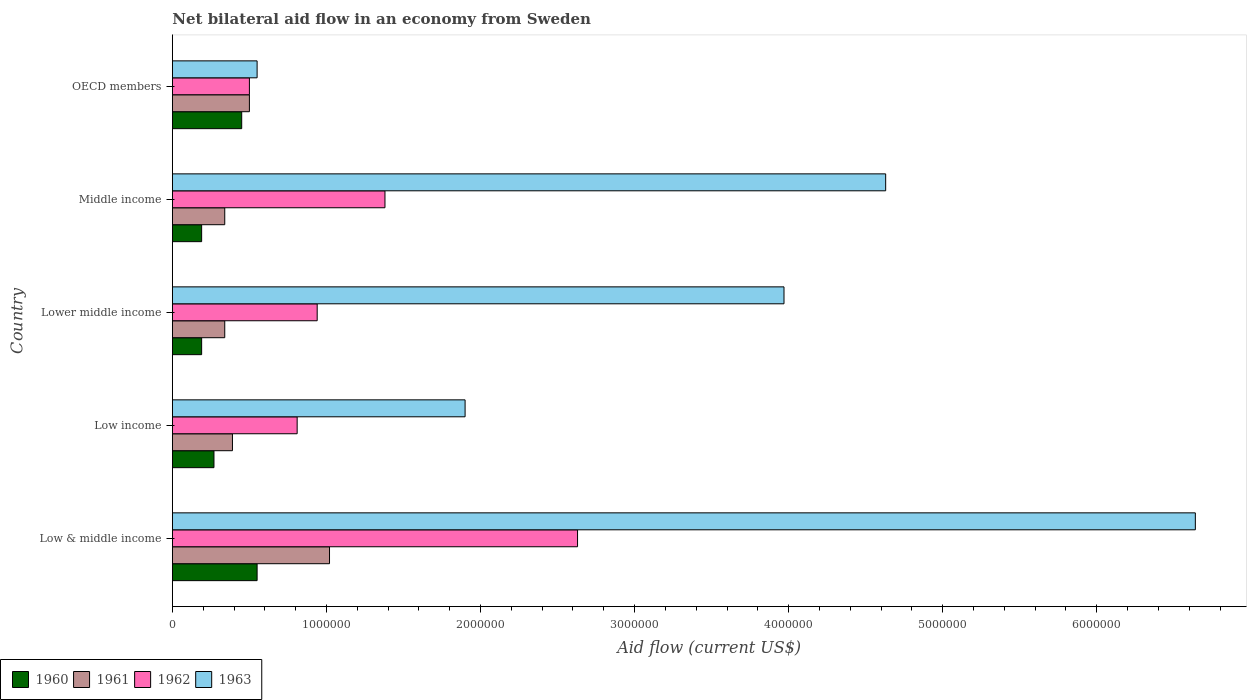How many different coloured bars are there?
Your answer should be very brief. 4. Are the number of bars on each tick of the Y-axis equal?
Keep it short and to the point. Yes. How many bars are there on the 5th tick from the top?
Your answer should be very brief. 4. How many bars are there on the 5th tick from the bottom?
Ensure brevity in your answer.  4. What is the label of the 2nd group of bars from the top?
Offer a terse response. Middle income. In how many cases, is the number of bars for a given country not equal to the number of legend labels?
Your answer should be very brief. 0. What is the net bilateral aid flow in 1960 in Low income?
Offer a terse response. 2.70e+05. In which country was the net bilateral aid flow in 1963 minimum?
Your response must be concise. OECD members. What is the total net bilateral aid flow in 1963 in the graph?
Offer a very short reply. 1.77e+07. What is the difference between the net bilateral aid flow in 1960 in Lower middle income and that in OECD members?
Keep it short and to the point. -2.60e+05. What is the difference between the net bilateral aid flow in 1961 in Lower middle income and the net bilateral aid flow in 1963 in Low & middle income?
Make the answer very short. -6.30e+06. What is the average net bilateral aid flow in 1963 per country?
Give a very brief answer. 3.54e+06. What is the difference between the net bilateral aid flow in 1960 and net bilateral aid flow in 1963 in Low & middle income?
Make the answer very short. -6.09e+06. In how many countries, is the net bilateral aid flow in 1963 greater than 2400000 US$?
Your response must be concise. 3. What is the ratio of the net bilateral aid flow in 1961 in Middle income to that in OECD members?
Your answer should be very brief. 0.68. Is the difference between the net bilateral aid flow in 1960 in Lower middle income and Middle income greater than the difference between the net bilateral aid flow in 1963 in Lower middle income and Middle income?
Offer a terse response. Yes. What is the difference between the highest and the lowest net bilateral aid flow in 1962?
Ensure brevity in your answer.  2.13e+06. Is the sum of the net bilateral aid flow in 1962 in Low income and Middle income greater than the maximum net bilateral aid flow in 1963 across all countries?
Offer a very short reply. No. Is it the case that in every country, the sum of the net bilateral aid flow in 1961 and net bilateral aid flow in 1962 is greater than the sum of net bilateral aid flow in 1960 and net bilateral aid flow in 1963?
Your response must be concise. No. What does the 2nd bar from the bottom in Middle income represents?
Offer a very short reply. 1961. How many bars are there?
Make the answer very short. 20. Are all the bars in the graph horizontal?
Provide a short and direct response. Yes. How many countries are there in the graph?
Make the answer very short. 5. Are the values on the major ticks of X-axis written in scientific E-notation?
Ensure brevity in your answer.  No. Does the graph contain any zero values?
Offer a very short reply. No. Does the graph contain grids?
Give a very brief answer. No. Where does the legend appear in the graph?
Give a very brief answer. Bottom left. How are the legend labels stacked?
Your answer should be very brief. Horizontal. What is the title of the graph?
Keep it short and to the point. Net bilateral aid flow in an economy from Sweden. Does "1964" appear as one of the legend labels in the graph?
Provide a short and direct response. No. What is the label or title of the Y-axis?
Keep it short and to the point. Country. What is the Aid flow (current US$) of 1960 in Low & middle income?
Provide a succinct answer. 5.50e+05. What is the Aid flow (current US$) of 1961 in Low & middle income?
Keep it short and to the point. 1.02e+06. What is the Aid flow (current US$) of 1962 in Low & middle income?
Ensure brevity in your answer.  2.63e+06. What is the Aid flow (current US$) in 1963 in Low & middle income?
Your answer should be very brief. 6.64e+06. What is the Aid flow (current US$) of 1962 in Low income?
Your answer should be compact. 8.10e+05. What is the Aid flow (current US$) in 1963 in Low income?
Your response must be concise. 1.90e+06. What is the Aid flow (current US$) of 1961 in Lower middle income?
Provide a short and direct response. 3.40e+05. What is the Aid flow (current US$) in 1962 in Lower middle income?
Give a very brief answer. 9.40e+05. What is the Aid flow (current US$) in 1963 in Lower middle income?
Keep it short and to the point. 3.97e+06. What is the Aid flow (current US$) of 1962 in Middle income?
Make the answer very short. 1.38e+06. What is the Aid flow (current US$) in 1963 in Middle income?
Keep it short and to the point. 4.63e+06. What is the Aid flow (current US$) of 1961 in OECD members?
Your response must be concise. 5.00e+05. What is the Aid flow (current US$) of 1962 in OECD members?
Provide a succinct answer. 5.00e+05. Across all countries, what is the maximum Aid flow (current US$) in 1960?
Offer a terse response. 5.50e+05. Across all countries, what is the maximum Aid flow (current US$) in 1961?
Make the answer very short. 1.02e+06. Across all countries, what is the maximum Aid flow (current US$) in 1962?
Give a very brief answer. 2.63e+06. Across all countries, what is the maximum Aid flow (current US$) in 1963?
Give a very brief answer. 6.64e+06. Across all countries, what is the minimum Aid flow (current US$) of 1963?
Keep it short and to the point. 5.50e+05. What is the total Aid flow (current US$) in 1960 in the graph?
Your answer should be very brief. 1.65e+06. What is the total Aid flow (current US$) in 1961 in the graph?
Offer a very short reply. 2.59e+06. What is the total Aid flow (current US$) in 1962 in the graph?
Your answer should be compact. 6.26e+06. What is the total Aid flow (current US$) of 1963 in the graph?
Your answer should be very brief. 1.77e+07. What is the difference between the Aid flow (current US$) of 1961 in Low & middle income and that in Low income?
Provide a succinct answer. 6.30e+05. What is the difference between the Aid flow (current US$) in 1962 in Low & middle income and that in Low income?
Make the answer very short. 1.82e+06. What is the difference between the Aid flow (current US$) in 1963 in Low & middle income and that in Low income?
Offer a terse response. 4.74e+06. What is the difference between the Aid flow (current US$) in 1961 in Low & middle income and that in Lower middle income?
Offer a very short reply. 6.80e+05. What is the difference between the Aid flow (current US$) of 1962 in Low & middle income and that in Lower middle income?
Offer a terse response. 1.69e+06. What is the difference between the Aid flow (current US$) in 1963 in Low & middle income and that in Lower middle income?
Your answer should be very brief. 2.67e+06. What is the difference between the Aid flow (current US$) of 1961 in Low & middle income and that in Middle income?
Your response must be concise. 6.80e+05. What is the difference between the Aid flow (current US$) in 1962 in Low & middle income and that in Middle income?
Keep it short and to the point. 1.25e+06. What is the difference between the Aid flow (current US$) of 1963 in Low & middle income and that in Middle income?
Make the answer very short. 2.01e+06. What is the difference between the Aid flow (current US$) in 1960 in Low & middle income and that in OECD members?
Your response must be concise. 1.00e+05. What is the difference between the Aid flow (current US$) in 1961 in Low & middle income and that in OECD members?
Ensure brevity in your answer.  5.20e+05. What is the difference between the Aid flow (current US$) in 1962 in Low & middle income and that in OECD members?
Ensure brevity in your answer.  2.13e+06. What is the difference between the Aid flow (current US$) of 1963 in Low & middle income and that in OECD members?
Offer a terse response. 6.09e+06. What is the difference between the Aid flow (current US$) in 1960 in Low income and that in Lower middle income?
Your answer should be compact. 8.00e+04. What is the difference between the Aid flow (current US$) in 1962 in Low income and that in Lower middle income?
Your answer should be compact. -1.30e+05. What is the difference between the Aid flow (current US$) in 1963 in Low income and that in Lower middle income?
Provide a short and direct response. -2.07e+06. What is the difference between the Aid flow (current US$) in 1961 in Low income and that in Middle income?
Keep it short and to the point. 5.00e+04. What is the difference between the Aid flow (current US$) of 1962 in Low income and that in Middle income?
Provide a short and direct response. -5.70e+05. What is the difference between the Aid flow (current US$) in 1963 in Low income and that in Middle income?
Your response must be concise. -2.73e+06. What is the difference between the Aid flow (current US$) in 1960 in Low income and that in OECD members?
Your answer should be compact. -1.80e+05. What is the difference between the Aid flow (current US$) in 1961 in Low income and that in OECD members?
Give a very brief answer. -1.10e+05. What is the difference between the Aid flow (current US$) of 1963 in Low income and that in OECD members?
Your answer should be compact. 1.35e+06. What is the difference between the Aid flow (current US$) in 1960 in Lower middle income and that in Middle income?
Keep it short and to the point. 0. What is the difference between the Aid flow (current US$) of 1961 in Lower middle income and that in Middle income?
Provide a succinct answer. 0. What is the difference between the Aid flow (current US$) in 1962 in Lower middle income and that in Middle income?
Your answer should be very brief. -4.40e+05. What is the difference between the Aid flow (current US$) in 1963 in Lower middle income and that in Middle income?
Your answer should be compact. -6.60e+05. What is the difference between the Aid flow (current US$) of 1960 in Lower middle income and that in OECD members?
Offer a terse response. -2.60e+05. What is the difference between the Aid flow (current US$) of 1961 in Lower middle income and that in OECD members?
Provide a succinct answer. -1.60e+05. What is the difference between the Aid flow (current US$) of 1963 in Lower middle income and that in OECD members?
Offer a very short reply. 3.42e+06. What is the difference between the Aid flow (current US$) in 1960 in Middle income and that in OECD members?
Provide a succinct answer. -2.60e+05. What is the difference between the Aid flow (current US$) in 1962 in Middle income and that in OECD members?
Ensure brevity in your answer.  8.80e+05. What is the difference between the Aid flow (current US$) of 1963 in Middle income and that in OECD members?
Make the answer very short. 4.08e+06. What is the difference between the Aid flow (current US$) in 1960 in Low & middle income and the Aid flow (current US$) in 1961 in Low income?
Offer a terse response. 1.60e+05. What is the difference between the Aid flow (current US$) in 1960 in Low & middle income and the Aid flow (current US$) in 1962 in Low income?
Offer a very short reply. -2.60e+05. What is the difference between the Aid flow (current US$) in 1960 in Low & middle income and the Aid flow (current US$) in 1963 in Low income?
Your answer should be compact. -1.35e+06. What is the difference between the Aid flow (current US$) in 1961 in Low & middle income and the Aid flow (current US$) in 1963 in Low income?
Ensure brevity in your answer.  -8.80e+05. What is the difference between the Aid flow (current US$) in 1962 in Low & middle income and the Aid flow (current US$) in 1963 in Low income?
Keep it short and to the point. 7.30e+05. What is the difference between the Aid flow (current US$) in 1960 in Low & middle income and the Aid flow (current US$) in 1961 in Lower middle income?
Make the answer very short. 2.10e+05. What is the difference between the Aid flow (current US$) in 1960 in Low & middle income and the Aid flow (current US$) in 1962 in Lower middle income?
Offer a terse response. -3.90e+05. What is the difference between the Aid flow (current US$) of 1960 in Low & middle income and the Aid flow (current US$) of 1963 in Lower middle income?
Provide a short and direct response. -3.42e+06. What is the difference between the Aid flow (current US$) in 1961 in Low & middle income and the Aid flow (current US$) in 1963 in Lower middle income?
Your answer should be compact. -2.95e+06. What is the difference between the Aid flow (current US$) of 1962 in Low & middle income and the Aid flow (current US$) of 1963 in Lower middle income?
Ensure brevity in your answer.  -1.34e+06. What is the difference between the Aid flow (current US$) in 1960 in Low & middle income and the Aid flow (current US$) in 1962 in Middle income?
Offer a very short reply. -8.30e+05. What is the difference between the Aid flow (current US$) of 1960 in Low & middle income and the Aid flow (current US$) of 1963 in Middle income?
Offer a terse response. -4.08e+06. What is the difference between the Aid flow (current US$) in 1961 in Low & middle income and the Aid flow (current US$) in 1962 in Middle income?
Keep it short and to the point. -3.60e+05. What is the difference between the Aid flow (current US$) in 1961 in Low & middle income and the Aid flow (current US$) in 1963 in Middle income?
Your response must be concise. -3.61e+06. What is the difference between the Aid flow (current US$) in 1960 in Low & middle income and the Aid flow (current US$) in 1961 in OECD members?
Give a very brief answer. 5.00e+04. What is the difference between the Aid flow (current US$) of 1960 in Low & middle income and the Aid flow (current US$) of 1962 in OECD members?
Your answer should be compact. 5.00e+04. What is the difference between the Aid flow (current US$) in 1960 in Low & middle income and the Aid flow (current US$) in 1963 in OECD members?
Offer a terse response. 0. What is the difference between the Aid flow (current US$) in 1961 in Low & middle income and the Aid flow (current US$) in 1962 in OECD members?
Your answer should be very brief. 5.20e+05. What is the difference between the Aid flow (current US$) of 1962 in Low & middle income and the Aid flow (current US$) of 1963 in OECD members?
Keep it short and to the point. 2.08e+06. What is the difference between the Aid flow (current US$) in 1960 in Low income and the Aid flow (current US$) in 1962 in Lower middle income?
Give a very brief answer. -6.70e+05. What is the difference between the Aid flow (current US$) in 1960 in Low income and the Aid flow (current US$) in 1963 in Lower middle income?
Provide a succinct answer. -3.70e+06. What is the difference between the Aid flow (current US$) in 1961 in Low income and the Aid flow (current US$) in 1962 in Lower middle income?
Your answer should be compact. -5.50e+05. What is the difference between the Aid flow (current US$) in 1961 in Low income and the Aid flow (current US$) in 1963 in Lower middle income?
Ensure brevity in your answer.  -3.58e+06. What is the difference between the Aid flow (current US$) of 1962 in Low income and the Aid flow (current US$) of 1963 in Lower middle income?
Your response must be concise. -3.16e+06. What is the difference between the Aid flow (current US$) of 1960 in Low income and the Aid flow (current US$) of 1962 in Middle income?
Give a very brief answer. -1.11e+06. What is the difference between the Aid flow (current US$) in 1960 in Low income and the Aid flow (current US$) in 1963 in Middle income?
Make the answer very short. -4.36e+06. What is the difference between the Aid flow (current US$) in 1961 in Low income and the Aid flow (current US$) in 1962 in Middle income?
Give a very brief answer. -9.90e+05. What is the difference between the Aid flow (current US$) in 1961 in Low income and the Aid flow (current US$) in 1963 in Middle income?
Provide a short and direct response. -4.24e+06. What is the difference between the Aid flow (current US$) in 1962 in Low income and the Aid flow (current US$) in 1963 in Middle income?
Provide a short and direct response. -3.82e+06. What is the difference between the Aid flow (current US$) of 1960 in Low income and the Aid flow (current US$) of 1963 in OECD members?
Ensure brevity in your answer.  -2.80e+05. What is the difference between the Aid flow (current US$) in 1961 in Low income and the Aid flow (current US$) in 1962 in OECD members?
Your response must be concise. -1.10e+05. What is the difference between the Aid flow (current US$) of 1961 in Low income and the Aid flow (current US$) of 1963 in OECD members?
Offer a very short reply. -1.60e+05. What is the difference between the Aid flow (current US$) of 1960 in Lower middle income and the Aid flow (current US$) of 1962 in Middle income?
Provide a succinct answer. -1.19e+06. What is the difference between the Aid flow (current US$) in 1960 in Lower middle income and the Aid flow (current US$) in 1963 in Middle income?
Offer a terse response. -4.44e+06. What is the difference between the Aid flow (current US$) in 1961 in Lower middle income and the Aid flow (current US$) in 1962 in Middle income?
Give a very brief answer. -1.04e+06. What is the difference between the Aid flow (current US$) of 1961 in Lower middle income and the Aid flow (current US$) of 1963 in Middle income?
Offer a terse response. -4.29e+06. What is the difference between the Aid flow (current US$) of 1962 in Lower middle income and the Aid flow (current US$) of 1963 in Middle income?
Give a very brief answer. -3.69e+06. What is the difference between the Aid flow (current US$) in 1960 in Lower middle income and the Aid flow (current US$) in 1961 in OECD members?
Offer a terse response. -3.10e+05. What is the difference between the Aid flow (current US$) of 1960 in Lower middle income and the Aid flow (current US$) of 1962 in OECD members?
Ensure brevity in your answer.  -3.10e+05. What is the difference between the Aid flow (current US$) in 1960 in Lower middle income and the Aid flow (current US$) in 1963 in OECD members?
Your answer should be very brief. -3.60e+05. What is the difference between the Aid flow (current US$) of 1961 in Lower middle income and the Aid flow (current US$) of 1962 in OECD members?
Provide a short and direct response. -1.60e+05. What is the difference between the Aid flow (current US$) of 1961 in Lower middle income and the Aid flow (current US$) of 1963 in OECD members?
Offer a very short reply. -2.10e+05. What is the difference between the Aid flow (current US$) of 1960 in Middle income and the Aid flow (current US$) of 1961 in OECD members?
Offer a terse response. -3.10e+05. What is the difference between the Aid flow (current US$) in 1960 in Middle income and the Aid flow (current US$) in 1962 in OECD members?
Your answer should be compact. -3.10e+05. What is the difference between the Aid flow (current US$) in 1960 in Middle income and the Aid flow (current US$) in 1963 in OECD members?
Ensure brevity in your answer.  -3.60e+05. What is the difference between the Aid flow (current US$) of 1961 in Middle income and the Aid flow (current US$) of 1962 in OECD members?
Offer a terse response. -1.60e+05. What is the difference between the Aid flow (current US$) in 1962 in Middle income and the Aid flow (current US$) in 1963 in OECD members?
Your response must be concise. 8.30e+05. What is the average Aid flow (current US$) of 1960 per country?
Offer a terse response. 3.30e+05. What is the average Aid flow (current US$) in 1961 per country?
Give a very brief answer. 5.18e+05. What is the average Aid flow (current US$) of 1962 per country?
Provide a short and direct response. 1.25e+06. What is the average Aid flow (current US$) in 1963 per country?
Your answer should be compact. 3.54e+06. What is the difference between the Aid flow (current US$) of 1960 and Aid flow (current US$) of 1961 in Low & middle income?
Provide a short and direct response. -4.70e+05. What is the difference between the Aid flow (current US$) in 1960 and Aid flow (current US$) in 1962 in Low & middle income?
Provide a short and direct response. -2.08e+06. What is the difference between the Aid flow (current US$) in 1960 and Aid flow (current US$) in 1963 in Low & middle income?
Provide a short and direct response. -6.09e+06. What is the difference between the Aid flow (current US$) of 1961 and Aid flow (current US$) of 1962 in Low & middle income?
Provide a short and direct response. -1.61e+06. What is the difference between the Aid flow (current US$) in 1961 and Aid flow (current US$) in 1963 in Low & middle income?
Provide a succinct answer. -5.62e+06. What is the difference between the Aid flow (current US$) of 1962 and Aid flow (current US$) of 1963 in Low & middle income?
Your answer should be very brief. -4.01e+06. What is the difference between the Aid flow (current US$) in 1960 and Aid flow (current US$) in 1962 in Low income?
Provide a succinct answer. -5.40e+05. What is the difference between the Aid flow (current US$) of 1960 and Aid flow (current US$) of 1963 in Low income?
Provide a short and direct response. -1.63e+06. What is the difference between the Aid flow (current US$) in 1961 and Aid flow (current US$) in 1962 in Low income?
Make the answer very short. -4.20e+05. What is the difference between the Aid flow (current US$) in 1961 and Aid flow (current US$) in 1963 in Low income?
Ensure brevity in your answer.  -1.51e+06. What is the difference between the Aid flow (current US$) of 1962 and Aid flow (current US$) of 1963 in Low income?
Your answer should be compact. -1.09e+06. What is the difference between the Aid flow (current US$) in 1960 and Aid flow (current US$) in 1961 in Lower middle income?
Ensure brevity in your answer.  -1.50e+05. What is the difference between the Aid flow (current US$) in 1960 and Aid flow (current US$) in 1962 in Lower middle income?
Ensure brevity in your answer.  -7.50e+05. What is the difference between the Aid flow (current US$) in 1960 and Aid flow (current US$) in 1963 in Lower middle income?
Your response must be concise. -3.78e+06. What is the difference between the Aid flow (current US$) of 1961 and Aid flow (current US$) of 1962 in Lower middle income?
Make the answer very short. -6.00e+05. What is the difference between the Aid flow (current US$) of 1961 and Aid flow (current US$) of 1963 in Lower middle income?
Keep it short and to the point. -3.63e+06. What is the difference between the Aid flow (current US$) in 1962 and Aid flow (current US$) in 1963 in Lower middle income?
Offer a very short reply. -3.03e+06. What is the difference between the Aid flow (current US$) of 1960 and Aid flow (current US$) of 1962 in Middle income?
Your answer should be very brief. -1.19e+06. What is the difference between the Aid flow (current US$) in 1960 and Aid flow (current US$) in 1963 in Middle income?
Give a very brief answer. -4.44e+06. What is the difference between the Aid flow (current US$) of 1961 and Aid flow (current US$) of 1962 in Middle income?
Provide a succinct answer. -1.04e+06. What is the difference between the Aid flow (current US$) in 1961 and Aid flow (current US$) in 1963 in Middle income?
Ensure brevity in your answer.  -4.29e+06. What is the difference between the Aid flow (current US$) of 1962 and Aid flow (current US$) of 1963 in Middle income?
Offer a very short reply. -3.25e+06. What is the difference between the Aid flow (current US$) in 1960 and Aid flow (current US$) in 1962 in OECD members?
Your answer should be compact. -5.00e+04. What is the difference between the Aid flow (current US$) in 1960 and Aid flow (current US$) in 1963 in OECD members?
Provide a short and direct response. -1.00e+05. What is the difference between the Aid flow (current US$) of 1961 and Aid flow (current US$) of 1962 in OECD members?
Make the answer very short. 0. What is the difference between the Aid flow (current US$) in 1961 and Aid flow (current US$) in 1963 in OECD members?
Make the answer very short. -5.00e+04. What is the difference between the Aid flow (current US$) in 1962 and Aid flow (current US$) in 1963 in OECD members?
Your response must be concise. -5.00e+04. What is the ratio of the Aid flow (current US$) of 1960 in Low & middle income to that in Low income?
Ensure brevity in your answer.  2.04. What is the ratio of the Aid flow (current US$) in 1961 in Low & middle income to that in Low income?
Your response must be concise. 2.62. What is the ratio of the Aid flow (current US$) in 1962 in Low & middle income to that in Low income?
Provide a succinct answer. 3.25. What is the ratio of the Aid flow (current US$) in 1963 in Low & middle income to that in Low income?
Your answer should be compact. 3.49. What is the ratio of the Aid flow (current US$) in 1960 in Low & middle income to that in Lower middle income?
Offer a terse response. 2.89. What is the ratio of the Aid flow (current US$) of 1961 in Low & middle income to that in Lower middle income?
Give a very brief answer. 3. What is the ratio of the Aid flow (current US$) of 1962 in Low & middle income to that in Lower middle income?
Provide a succinct answer. 2.8. What is the ratio of the Aid flow (current US$) of 1963 in Low & middle income to that in Lower middle income?
Give a very brief answer. 1.67. What is the ratio of the Aid flow (current US$) of 1960 in Low & middle income to that in Middle income?
Offer a terse response. 2.89. What is the ratio of the Aid flow (current US$) in 1962 in Low & middle income to that in Middle income?
Offer a very short reply. 1.91. What is the ratio of the Aid flow (current US$) in 1963 in Low & middle income to that in Middle income?
Keep it short and to the point. 1.43. What is the ratio of the Aid flow (current US$) of 1960 in Low & middle income to that in OECD members?
Your answer should be compact. 1.22. What is the ratio of the Aid flow (current US$) in 1961 in Low & middle income to that in OECD members?
Keep it short and to the point. 2.04. What is the ratio of the Aid flow (current US$) of 1962 in Low & middle income to that in OECD members?
Provide a short and direct response. 5.26. What is the ratio of the Aid flow (current US$) of 1963 in Low & middle income to that in OECD members?
Offer a very short reply. 12.07. What is the ratio of the Aid flow (current US$) in 1960 in Low income to that in Lower middle income?
Provide a short and direct response. 1.42. What is the ratio of the Aid flow (current US$) of 1961 in Low income to that in Lower middle income?
Keep it short and to the point. 1.15. What is the ratio of the Aid flow (current US$) of 1962 in Low income to that in Lower middle income?
Your response must be concise. 0.86. What is the ratio of the Aid flow (current US$) of 1963 in Low income to that in Lower middle income?
Make the answer very short. 0.48. What is the ratio of the Aid flow (current US$) in 1960 in Low income to that in Middle income?
Your answer should be compact. 1.42. What is the ratio of the Aid flow (current US$) in 1961 in Low income to that in Middle income?
Your answer should be very brief. 1.15. What is the ratio of the Aid flow (current US$) in 1962 in Low income to that in Middle income?
Make the answer very short. 0.59. What is the ratio of the Aid flow (current US$) of 1963 in Low income to that in Middle income?
Offer a terse response. 0.41. What is the ratio of the Aid flow (current US$) in 1961 in Low income to that in OECD members?
Offer a terse response. 0.78. What is the ratio of the Aid flow (current US$) of 1962 in Low income to that in OECD members?
Provide a succinct answer. 1.62. What is the ratio of the Aid flow (current US$) in 1963 in Low income to that in OECD members?
Provide a succinct answer. 3.45. What is the ratio of the Aid flow (current US$) of 1962 in Lower middle income to that in Middle income?
Your answer should be compact. 0.68. What is the ratio of the Aid flow (current US$) in 1963 in Lower middle income to that in Middle income?
Provide a succinct answer. 0.86. What is the ratio of the Aid flow (current US$) of 1960 in Lower middle income to that in OECD members?
Provide a short and direct response. 0.42. What is the ratio of the Aid flow (current US$) of 1961 in Lower middle income to that in OECD members?
Give a very brief answer. 0.68. What is the ratio of the Aid flow (current US$) of 1962 in Lower middle income to that in OECD members?
Give a very brief answer. 1.88. What is the ratio of the Aid flow (current US$) of 1963 in Lower middle income to that in OECD members?
Your answer should be very brief. 7.22. What is the ratio of the Aid flow (current US$) in 1960 in Middle income to that in OECD members?
Your answer should be very brief. 0.42. What is the ratio of the Aid flow (current US$) of 1961 in Middle income to that in OECD members?
Offer a terse response. 0.68. What is the ratio of the Aid flow (current US$) of 1962 in Middle income to that in OECD members?
Your answer should be compact. 2.76. What is the ratio of the Aid flow (current US$) in 1963 in Middle income to that in OECD members?
Your answer should be very brief. 8.42. What is the difference between the highest and the second highest Aid flow (current US$) of 1961?
Offer a very short reply. 5.20e+05. What is the difference between the highest and the second highest Aid flow (current US$) of 1962?
Your answer should be very brief. 1.25e+06. What is the difference between the highest and the second highest Aid flow (current US$) in 1963?
Offer a very short reply. 2.01e+06. What is the difference between the highest and the lowest Aid flow (current US$) in 1961?
Offer a terse response. 6.80e+05. What is the difference between the highest and the lowest Aid flow (current US$) in 1962?
Offer a terse response. 2.13e+06. What is the difference between the highest and the lowest Aid flow (current US$) in 1963?
Ensure brevity in your answer.  6.09e+06. 